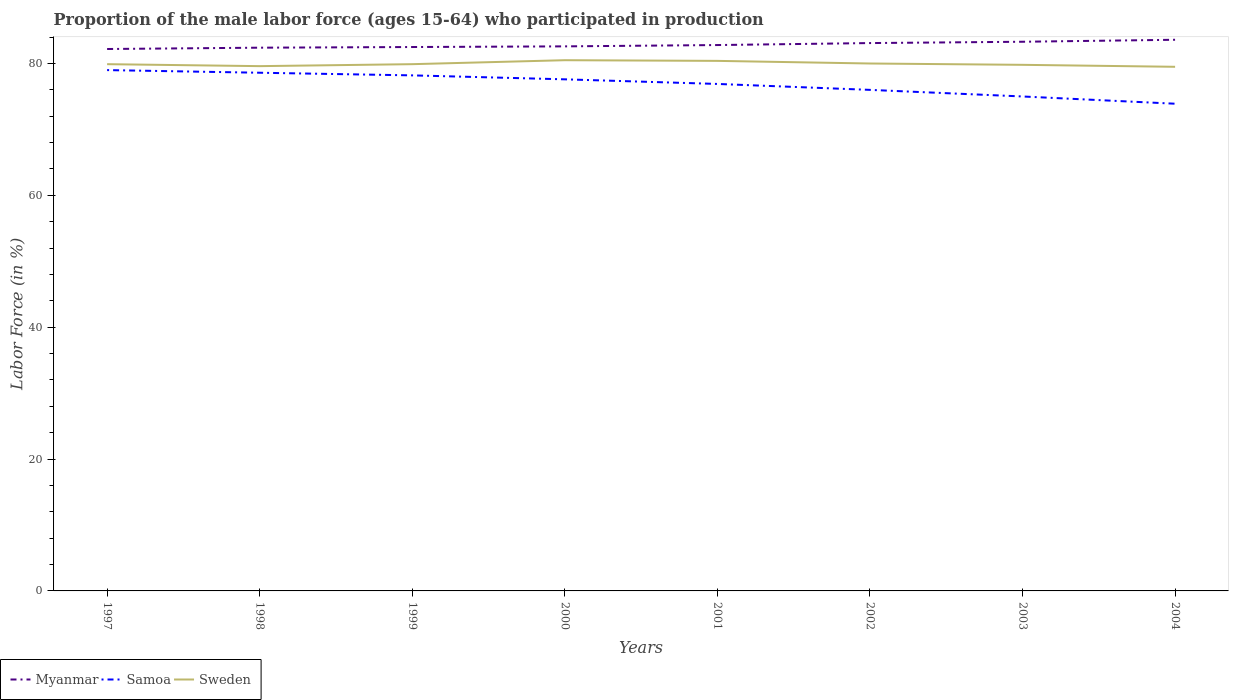Is the number of lines equal to the number of legend labels?
Offer a very short reply. Yes. Across all years, what is the maximum proportion of the male labor force who participated in production in Samoa?
Provide a short and direct response. 73.9. What is the total proportion of the male labor force who participated in production in Myanmar in the graph?
Ensure brevity in your answer.  -0.2. What is the difference between the highest and the second highest proportion of the male labor force who participated in production in Myanmar?
Ensure brevity in your answer.  1.4. What is the difference between two consecutive major ticks on the Y-axis?
Ensure brevity in your answer.  20. Are the values on the major ticks of Y-axis written in scientific E-notation?
Your answer should be very brief. No. Does the graph contain any zero values?
Give a very brief answer. No. What is the title of the graph?
Offer a terse response. Proportion of the male labor force (ages 15-64) who participated in production. What is the label or title of the Y-axis?
Provide a succinct answer. Labor Force (in %). What is the Labor Force (in %) of Myanmar in 1997?
Your answer should be compact. 82.2. What is the Labor Force (in %) in Samoa in 1997?
Your response must be concise. 79. What is the Labor Force (in %) in Sweden in 1997?
Provide a short and direct response. 79.9. What is the Labor Force (in %) of Myanmar in 1998?
Provide a succinct answer. 82.4. What is the Labor Force (in %) of Samoa in 1998?
Make the answer very short. 78.6. What is the Labor Force (in %) in Sweden in 1998?
Provide a short and direct response. 79.6. What is the Labor Force (in %) in Myanmar in 1999?
Your answer should be compact. 82.5. What is the Labor Force (in %) of Samoa in 1999?
Your answer should be compact. 78.2. What is the Labor Force (in %) in Sweden in 1999?
Make the answer very short. 79.9. What is the Labor Force (in %) in Myanmar in 2000?
Provide a succinct answer. 82.6. What is the Labor Force (in %) in Samoa in 2000?
Ensure brevity in your answer.  77.6. What is the Labor Force (in %) in Sweden in 2000?
Your response must be concise. 80.5. What is the Labor Force (in %) of Myanmar in 2001?
Your answer should be very brief. 82.8. What is the Labor Force (in %) in Samoa in 2001?
Offer a terse response. 76.9. What is the Labor Force (in %) of Sweden in 2001?
Make the answer very short. 80.4. What is the Labor Force (in %) of Myanmar in 2002?
Give a very brief answer. 83.1. What is the Labor Force (in %) of Sweden in 2002?
Keep it short and to the point. 80. What is the Labor Force (in %) in Myanmar in 2003?
Your answer should be compact. 83.3. What is the Labor Force (in %) of Samoa in 2003?
Your response must be concise. 75. What is the Labor Force (in %) in Sweden in 2003?
Give a very brief answer. 79.8. What is the Labor Force (in %) of Myanmar in 2004?
Provide a short and direct response. 83.6. What is the Labor Force (in %) of Samoa in 2004?
Your response must be concise. 73.9. What is the Labor Force (in %) of Sweden in 2004?
Offer a terse response. 79.5. Across all years, what is the maximum Labor Force (in %) in Myanmar?
Ensure brevity in your answer.  83.6. Across all years, what is the maximum Labor Force (in %) in Samoa?
Offer a terse response. 79. Across all years, what is the maximum Labor Force (in %) in Sweden?
Keep it short and to the point. 80.5. Across all years, what is the minimum Labor Force (in %) in Myanmar?
Keep it short and to the point. 82.2. Across all years, what is the minimum Labor Force (in %) of Samoa?
Your answer should be very brief. 73.9. Across all years, what is the minimum Labor Force (in %) in Sweden?
Offer a terse response. 79.5. What is the total Labor Force (in %) of Myanmar in the graph?
Keep it short and to the point. 662.5. What is the total Labor Force (in %) of Samoa in the graph?
Provide a succinct answer. 615.2. What is the total Labor Force (in %) of Sweden in the graph?
Offer a terse response. 639.6. What is the difference between the Labor Force (in %) of Myanmar in 1997 and that in 1998?
Make the answer very short. -0.2. What is the difference between the Labor Force (in %) in Samoa in 1997 and that in 1998?
Provide a short and direct response. 0.4. What is the difference between the Labor Force (in %) of Sweden in 1997 and that in 1998?
Make the answer very short. 0.3. What is the difference between the Labor Force (in %) of Myanmar in 1997 and that in 1999?
Make the answer very short. -0.3. What is the difference between the Labor Force (in %) in Samoa in 1997 and that in 1999?
Ensure brevity in your answer.  0.8. What is the difference between the Labor Force (in %) of Sweden in 1997 and that in 1999?
Give a very brief answer. 0. What is the difference between the Labor Force (in %) in Sweden in 1997 and that in 2000?
Ensure brevity in your answer.  -0.6. What is the difference between the Labor Force (in %) of Samoa in 1997 and that in 2001?
Ensure brevity in your answer.  2.1. What is the difference between the Labor Force (in %) in Sweden in 1997 and that in 2001?
Make the answer very short. -0.5. What is the difference between the Labor Force (in %) of Myanmar in 1997 and that in 2002?
Keep it short and to the point. -0.9. What is the difference between the Labor Force (in %) in Sweden in 1997 and that in 2002?
Provide a succinct answer. -0.1. What is the difference between the Labor Force (in %) in Myanmar in 1997 and that in 2003?
Keep it short and to the point. -1.1. What is the difference between the Labor Force (in %) in Samoa in 1997 and that in 2004?
Offer a very short reply. 5.1. What is the difference between the Labor Force (in %) of Sweden in 1998 and that in 1999?
Your answer should be very brief. -0.3. What is the difference between the Labor Force (in %) of Myanmar in 1998 and that in 2000?
Ensure brevity in your answer.  -0.2. What is the difference between the Labor Force (in %) in Sweden in 1998 and that in 2000?
Offer a very short reply. -0.9. What is the difference between the Labor Force (in %) in Myanmar in 1998 and that in 2001?
Provide a succinct answer. -0.4. What is the difference between the Labor Force (in %) in Sweden in 1998 and that in 2001?
Provide a short and direct response. -0.8. What is the difference between the Labor Force (in %) of Sweden in 1998 and that in 2002?
Offer a very short reply. -0.4. What is the difference between the Labor Force (in %) in Samoa in 1998 and that in 2003?
Provide a succinct answer. 3.6. What is the difference between the Labor Force (in %) in Sweden in 1998 and that in 2003?
Provide a short and direct response. -0.2. What is the difference between the Labor Force (in %) in Sweden in 1998 and that in 2004?
Your answer should be very brief. 0.1. What is the difference between the Labor Force (in %) in Myanmar in 1999 and that in 2000?
Offer a terse response. -0.1. What is the difference between the Labor Force (in %) of Myanmar in 1999 and that in 2001?
Offer a very short reply. -0.3. What is the difference between the Labor Force (in %) of Sweden in 1999 and that in 2001?
Ensure brevity in your answer.  -0.5. What is the difference between the Labor Force (in %) of Samoa in 1999 and that in 2002?
Your answer should be compact. 2.2. What is the difference between the Labor Force (in %) of Sweden in 1999 and that in 2002?
Make the answer very short. -0.1. What is the difference between the Labor Force (in %) of Samoa in 1999 and that in 2003?
Make the answer very short. 3.2. What is the difference between the Labor Force (in %) of Samoa in 1999 and that in 2004?
Make the answer very short. 4.3. What is the difference between the Labor Force (in %) in Sweden in 1999 and that in 2004?
Your answer should be compact. 0.4. What is the difference between the Labor Force (in %) of Myanmar in 2000 and that in 2001?
Offer a terse response. -0.2. What is the difference between the Labor Force (in %) in Sweden in 2000 and that in 2001?
Give a very brief answer. 0.1. What is the difference between the Labor Force (in %) of Myanmar in 2000 and that in 2002?
Make the answer very short. -0.5. What is the difference between the Labor Force (in %) in Samoa in 2000 and that in 2002?
Give a very brief answer. 1.6. What is the difference between the Labor Force (in %) in Myanmar in 2000 and that in 2003?
Your answer should be compact. -0.7. What is the difference between the Labor Force (in %) in Samoa in 2000 and that in 2003?
Offer a terse response. 2.6. What is the difference between the Labor Force (in %) in Myanmar in 2000 and that in 2004?
Offer a very short reply. -1. What is the difference between the Labor Force (in %) in Samoa in 2000 and that in 2004?
Offer a very short reply. 3.7. What is the difference between the Labor Force (in %) in Sweden in 2000 and that in 2004?
Ensure brevity in your answer.  1. What is the difference between the Labor Force (in %) in Myanmar in 2001 and that in 2002?
Provide a succinct answer. -0.3. What is the difference between the Labor Force (in %) in Samoa in 2001 and that in 2002?
Your answer should be compact. 0.9. What is the difference between the Labor Force (in %) of Samoa in 2001 and that in 2003?
Offer a very short reply. 1.9. What is the difference between the Labor Force (in %) in Myanmar in 2001 and that in 2004?
Give a very brief answer. -0.8. What is the difference between the Labor Force (in %) in Samoa in 2001 and that in 2004?
Make the answer very short. 3. What is the difference between the Labor Force (in %) of Sweden in 2001 and that in 2004?
Offer a very short reply. 0.9. What is the difference between the Labor Force (in %) in Samoa in 2002 and that in 2003?
Keep it short and to the point. 1. What is the difference between the Labor Force (in %) in Sweden in 2002 and that in 2004?
Offer a terse response. 0.5. What is the difference between the Labor Force (in %) in Myanmar in 2003 and that in 2004?
Ensure brevity in your answer.  -0.3. What is the difference between the Labor Force (in %) in Myanmar in 1997 and the Labor Force (in %) in Samoa in 1998?
Make the answer very short. 3.6. What is the difference between the Labor Force (in %) in Myanmar in 1997 and the Labor Force (in %) in Sweden in 1998?
Keep it short and to the point. 2.6. What is the difference between the Labor Force (in %) in Myanmar in 1997 and the Labor Force (in %) in Samoa in 1999?
Your answer should be compact. 4. What is the difference between the Labor Force (in %) in Samoa in 1997 and the Labor Force (in %) in Sweden in 1999?
Your response must be concise. -0.9. What is the difference between the Labor Force (in %) in Myanmar in 1997 and the Labor Force (in %) in Sweden in 2000?
Your answer should be compact. 1.7. What is the difference between the Labor Force (in %) in Myanmar in 1997 and the Labor Force (in %) in Samoa in 2001?
Provide a succinct answer. 5.3. What is the difference between the Labor Force (in %) in Myanmar in 1997 and the Labor Force (in %) in Samoa in 2002?
Make the answer very short. 6.2. What is the difference between the Labor Force (in %) of Samoa in 1997 and the Labor Force (in %) of Sweden in 2002?
Make the answer very short. -1. What is the difference between the Labor Force (in %) of Myanmar in 1997 and the Labor Force (in %) of Samoa in 2003?
Provide a succinct answer. 7.2. What is the difference between the Labor Force (in %) in Myanmar in 1997 and the Labor Force (in %) in Sweden in 2003?
Your response must be concise. 2.4. What is the difference between the Labor Force (in %) in Myanmar in 1997 and the Labor Force (in %) in Samoa in 2004?
Keep it short and to the point. 8.3. What is the difference between the Labor Force (in %) of Samoa in 1998 and the Labor Force (in %) of Sweden in 2000?
Provide a short and direct response. -1.9. What is the difference between the Labor Force (in %) of Myanmar in 1998 and the Labor Force (in %) of Sweden in 2001?
Your answer should be very brief. 2. What is the difference between the Labor Force (in %) in Samoa in 1998 and the Labor Force (in %) in Sweden in 2001?
Keep it short and to the point. -1.8. What is the difference between the Labor Force (in %) of Myanmar in 1998 and the Labor Force (in %) of Samoa in 2002?
Your answer should be very brief. 6.4. What is the difference between the Labor Force (in %) in Myanmar in 1998 and the Labor Force (in %) in Samoa in 2003?
Provide a succinct answer. 7.4. What is the difference between the Labor Force (in %) in Myanmar in 1998 and the Labor Force (in %) in Sweden in 2003?
Offer a very short reply. 2.6. What is the difference between the Labor Force (in %) in Myanmar in 1998 and the Labor Force (in %) in Samoa in 2004?
Ensure brevity in your answer.  8.5. What is the difference between the Labor Force (in %) of Myanmar in 1998 and the Labor Force (in %) of Sweden in 2004?
Give a very brief answer. 2.9. What is the difference between the Labor Force (in %) of Samoa in 1998 and the Labor Force (in %) of Sweden in 2004?
Offer a very short reply. -0.9. What is the difference between the Labor Force (in %) in Myanmar in 1999 and the Labor Force (in %) in Samoa in 2000?
Provide a short and direct response. 4.9. What is the difference between the Labor Force (in %) in Samoa in 1999 and the Labor Force (in %) in Sweden in 2002?
Offer a terse response. -1.8. What is the difference between the Labor Force (in %) in Myanmar in 1999 and the Labor Force (in %) in Samoa in 2003?
Provide a succinct answer. 7.5. What is the difference between the Labor Force (in %) of Myanmar in 1999 and the Labor Force (in %) of Sweden in 2004?
Provide a succinct answer. 3. What is the difference between the Labor Force (in %) of Samoa in 1999 and the Labor Force (in %) of Sweden in 2004?
Give a very brief answer. -1.3. What is the difference between the Labor Force (in %) in Samoa in 2000 and the Labor Force (in %) in Sweden in 2001?
Provide a short and direct response. -2.8. What is the difference between the Labor Force (in %) in Samoa in 2000 and the Labor Force (in %) in Sweden in 2002?
Give a very brief answer. -2.4. What is the difference between the Labor Force (in %) of Myanmar in 2000 and the Labor Force (in %) of Samoa in 2003?
Offer a very short reply. 7.6. What is the difference between the Labor Force (in %) of Myanmar in 2000 and the Labor Force (in %) of Sweden in 2003?
Offer a very short reply. 2.8. What is the difference between the Labor Force (in %) in Samoa in 2000 and the Labor Force (in %) in Sweden in 2003?
Make the answer very short. -2.2. What is the difference between the Labor Force (in %) of Myanmar in 2001 and the Labor Force (in %) of Samoa in 2002?
Make the answer very short. 6.8. What is the difference between the Labor Force (in %) of Myanmar in 2001 and the Labor Force (in %) of Sweden in 2002?
Your response must be concise. 2.8. What is the difference between the Labor Force (in %) of Myanmar in 2001 and the Labor Force (in %) of Samoa in 2003?
Make the answer very short. 7.8. What is the difference between the Labor Force (in %) in Myanmar in 2001 and the Labor Force (in %) in Sweden in 2003?
Offer a very short reply. 3. What is the difference between the Labor Force (in %) in Myanmar in 2001 and the Labor Force (in %) in Samoa in 2004?
Keep it short and to the point. 8.9. What is the difference between the Labor Force (in %) in Myanmar in 2001 and the Labor Force (in %) in Sweden in 2004?
Offer a terse response. 3.3. What is the difference between the Labor Force (in %) of Samoa in 2001 and the Labor Force (in %) of Sweden in 2004?
Offer a terse response. -2.6. What is the difference between the Labor Force (in %) in Myanmar in 2002 and the Labor Force (in %) in Samoa in 2003?
Your answer should be very brief. 8.1. What is the difference between the Labor Force (in %) in Samoa in 2002 and the Labor Force (in %) in Sweden in 2003?
Provide a succinct answer. -3.8. What is the difference between the Labor Force (in %) of Myanmar in 2003 and the Labor Force (in %) of Sweden in 2004?
Your answer should be compact. 3.8. What is the difference between the Labor Force (in %) of Samoa in 2003 and the Labor Force (in %) of Sweden in 2004?
Give a very brief answer. -4.5. What is the average Labor Force (in %) in Myanmar per year?
Ensure brevity in your answer.  82.81. What is the average Labor Force (in %) of Samoa per year?
Your answer should be very brief. 76.9. What is the average Labor Force (in %) of Sweden per year?
Ensure brevity in your answer.  79.95. In the year 1997, what is the difference between the Labor Force (in %) of Myanmar and Labor Force (in %) of Sweden?
Provide a succinct answer. 2.3. In the year 1997, what is the difference between the Labor Force (in %) in Samoa and Labor Force (in %) in Sweden?
Your response must be concise. -0.9. In the year 1998, what is the difference between the Labor Force (in %) in Myanmar and Labor Force (in %) in Samoa?
Provide a short and direct response. 3.8. In the year 1998, what is the difference between the Labor Force (in %) of Myanmar and Labor Force (in %) of Sweden?
Give a very brief answer. 2.8. In the year 1998, what is the difference between the Labor Force (in %) of Samoa and Labor Force (in %) of Sweden?
Your answer should be compact. -1. In the year 1999, what is the difference between the Labor Force (in %) in Myanmar and Labor Force (in %) in Sweden?
Provide a short and direct response. 2.6. In the year 1999, what is the difference between the Labor Force (in %) of Samoa and Labor Force (in %) of Sweden?
Your response must be concise. -1.7. In the year 2000, what is the difference between the Labor Force (in %) of Myanmar and Labor Force (in %) of Samoa?
Your answer should be very brief. 5. In the year 2000, what is the difference between the Labor Force (in %) of Samoa and Labor Force (in %) of Sweden?
Provide a succinct answer. -2.9. In the year 2001, what is the difference between the Labor Force (in %) of Myanmar and Labor Force (in %) of Sweden?
Make the answer very short. 2.4. In the year 2002, what is the difference between the Labor Force (in %) in Myanmar and Labor Force (in %) in Sweden?
Ensure brevity in your answer.  3.1. In the year 2002, what is the difference between the Labor Force (in %) in Samoa and Labor Force (in %) in Sweden?
Your answer should be very brief. -4. In the year 2003, what is the difference between the Labor Force (in %) of Myanmar and Labor Force (in %) of Samoa?
Offer a very short reply. 8.3. In the year 2003, what is the difference between the Labor Force (in %) in Myanmar and Labor Force (in %) in Sweden?
Ensure brevity in your answer.  3.5. In the year 2004, what is the difference between the Labor Force (in %) in Myanmar and Labor Force (in %) in Sweden?
Make the answer very short. 4.1. What is the ratio of the Labor Force (in %) in Myanmar in 1997 to that in 1998?
Make the answer very short. 1. What is the ratio of the Labor Force (in %) of Samoa in 1997 to that in 1998?
Offer a terse response. 1.01. What is the ratio of the Labor Force (in %) of Sweden in 1997 to that in 1998?
Make the answer very short. 1. What is the ratio of the Labor Force (in %) of Samoa in 1997 to that in 1999?
Offer a terse response. 1.01. What is the ratio of the Labor Force (in %) of Sweden in 1997 to that in 1999?
Your response must be concise. 1. What is the ratio of the Labor Force (in %) in Myanmar in 1997 to that in 2000?
Ensure brevity in your answer.  1. What is the ratio of the Labor Force (in %) of Samoa in 1997 to that in 2000?
Your answer should be compact. 1.02. What is the ratio of the Labor Force (in %) in Myanmar in 1997 to that in 2001?
Ensure brevity in your answer.  0.99. What is the ratio of the Labor Force (in %) of Samoa in 1997 to that in 2001?
Offer a terse response. 1.03. What is the ratio of the Labor Force (in %) of Myanmar in 1997 to that in 2002?
Your answer should be compact. 0.99. What is the ratio of the Labor Force (in %) of Samoa in 1997 to that in 2002?
Your answer should be compact. 1.04. What is the ratio of the Labor Force (in %) of Myanmar in 1997 to that in 2003?
Your response must be concise. 0.99. What is the ratio of the Labor Force (in %) in Samoa in 1997 to that in 2003?
Offer a terse response. 1.05. What is the ratio of the Labor Force (in %) in Sweden in 1997 to that in 2003?
Offer a terse response. 1. What is the ratio of the Labor Force (in %) in Myanmar in 1997 to that in 2004?
Keep it short and to the point. 0.98. What is the ratio of the Labor Force (in %) in Samoa in 1997 to that in 2004?
Offer a terse response. 1.07. What is the ratio of the Labor Force (in %) of Sweden in 1997 to that in 2004?
Offer a very short reply. 1. What is the ratio of the Labor Force (in %) of Myanmar in 1998 to that in 1999?
Keep it short and to the point. 1. What is the ratio of the Labor Force (in %) of Myanmar in 1998 to that in 2000?
Your answer should be very brief. 1. What is the ratio of the Labor Force (in %) in Samoa in 1998 to that in 2000?
Make the answer very short. 1.01. What is the ratio of the Labor Force (in %) in Sweden in 1998 to that in 2000?
Offer a terse response. 0.99. What is the ratio of the Labor Force (in %) of Samoa in 1998 to that in 2001?
Offer a very short reply. 1.02. What is the ratio of the Labor Force (in %) of Myanmar in 1998 to that in 2002?
Give a very brief answer. 0.99. What is the ratio of the Labor Force (in %) in Samoa in 1998 to that in 2002?
Give a very brief answer. 1.03. What is the ratio of the Labor Force (in %) of Sweden in 1998 to that in 2002?
Your answer should be very brief. 0.99. What is the ratio of the Labor Force (in %) in Samoa in 1998 to that in 2003?
Your response must be concise. 1.05. What is the ratio of the Labor Force (in %) of Sweden in 1998 to that in 2003?
Ensure brevity in your answer.  1. What is the ratio of the Labor Force (in %) in Myanmar in 1998 to that in 2004?
Give a very brief answer. 0.99. What is the ratio of the Labor Force (in %) in Samoa in 1998 to that in 2004?
Your answer should be very brief. 1.06. What is the ratio of the Labor Force (in %) of Sweden in 1998 to that in 2004?
Keep it short and to the point. 1. What is the ratio of the Labor Force (in %) of Myanmar in 1999 to that in 2000?
Your answer should be compact. 1. What is the ratio of the Labor Force (in %) in Samoa in 1999 to that in 2000?
Make the answer very short. 1.01. What is the ratio of the Labor Force (in %) of Samoa in 1999 to that in 2001?
Keep it short and to the point. 1.02. What is the ratio of the Labor Force (in %) in Sweden in 1999 to that in 2001?
Your answer should be compact. 0.99. What is the ratio of the Labor Force (in %) in Samoa in 1999 to that in 2002?
Offer a very short reply. 1.03. What is the ratio of the Labor Force (in %) in Myanmar in 1999 to that in 2003?
Your answer should be very brief. 0.99. What is the ratio of the Labor Force (in %) in Samoa in 1999 to that in 2003?
Provide a short and direct response. 1.04. What is the ratio of the Labor Force (in %) in Sweden in 1999 to that in 2003?
Your answer should be very brief. 1. What is the ratio of the Labor Force (in %) of Myanmar in 1999 to that in 2004?
Keep it short and to the point. 0.99. What is the ratio of the Labor Force (in %) in Samoa in 1999 to that in 2004?
Make the answer very short. 1.06. What is the ratio of the Labor Force (in %) of Samoa in 2000 to that in 2001?
Provide a succinct answer. 1.01. What is the ratio of the Labor Force (in %) in Samoa in 2000 to that in 2002?
Your answer should be compact. 1.02. What is the ratio of the Labor Force (in %) of Sweden in 2000 to that in 2002?
Provide a short and direct response. 1.01. What is the ratio of the Labor Force (in %) in Samoa in 2000 to that in 2003?
Your answer should be very brief. 1.03. What is the ratio of the Labor Force (in %) in Sweden in 2000 to that in 2003?
Provide a succinct answer. 1.01. What is the ratio of the Labor Force (in %) in Myanmar in 2000 to that in 2004?
Provide a short and direct response. 0.99. What is the ratio of the Labor Force (in %) of Samoa in 2000 to that in 2004?
Provide a succinct answer. 1.05. What is the ratio of the Labor Force (in %) in Sweden in 2000 to that in 2004?
Provide a succinct answer. 1.01. What is the ratio of the Labor Force (in %) in Myanmar in 2001 to that in 2002?
Make the answer very short. 1. What is the ratio of the Labor Force (in %) of Samoa in 2001 to that in 2002?
Make the answer very short. 1.01. What is the ratio of the Labor Force (in %) in Sweden in 2001 to that in 2002?
Give a very brief answer. 1. What is the ratio of the Labor Force (in %) of Myanmar in 2001 to that in 2003?
Provide a succinct answer. 0.99. What is the ratio of the Labor Force (in %) in Samoa in 2001 to that in 2003?
Make the answer very short. 1.03. What is the ratio of the Labor Force (in %) in Sweden in 2001 to that in 2003?
Ensure brevity in your answer.  1.01. What is the ratio of the Labor Force (in %) in Myanmar in 2001 to that in 2004?
Offer a very short reply. 0.99. What is the ratio of the Labor Force (in %) of Samoa in 2001 to that in 2004?
Provide a succinct answer. 1.04. What is the ratio of the Labor Force (in %) of Sweden in 2001 to that in 2004?
Give a very brief answer. 1.01. What is the ratio of the Labor Force (in %) of Myanmar in 2002 to that in 2003?
Your answer should be very brief. 1. What is the ratio of the Labor Force (in %) of Samoa in 2002 to that in 2003?
Give a very brief answer. 1.01. What is the ratio of the Labor Force (in %) in Samoa in 2002 to that in 2004?
Keep it short and to the point. 1.03. What is the ratio of the Labor Force (in %) in Samoa in 2003 to that in 2004?
Keep it short and to the point. 1.01. What is the difference between the highest and the second highest Labor Force (in %) of Myanmar?
Your response must be concise. 0.3. What is the difference between the highest and the second highest Labor Force (in %) in Sweden?
Your response must be concise. 0.1. What is the difference between the highest and the lowest Labor Force (in %) in Myanmar?
Give a very brief answer. 1.4. What is the difference between the highest and the lowest Labor Force (in %) in Samoa?
Make the answer very short. 5.1. 